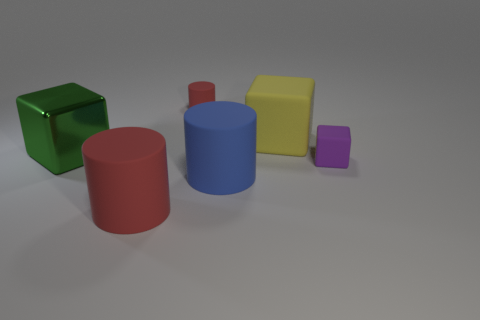Subtract 1 cylinders. How many cylinders are left? 2 Subtract all big cubes. How many cubes are left? 1 Add 1 big rubber cubes. How many objects exist? 7 Subtract 0 gray balls. How many objects are left? 6 Subtract all big metal cubes. Subtract all blue cylinders. How many objects are left? 4 Add 2 yellow matte cubes. How many yellow matte cubes are left? 3 Add 2 small yellow metallic cubes. How many small yellow metallic cubes exist? 2 